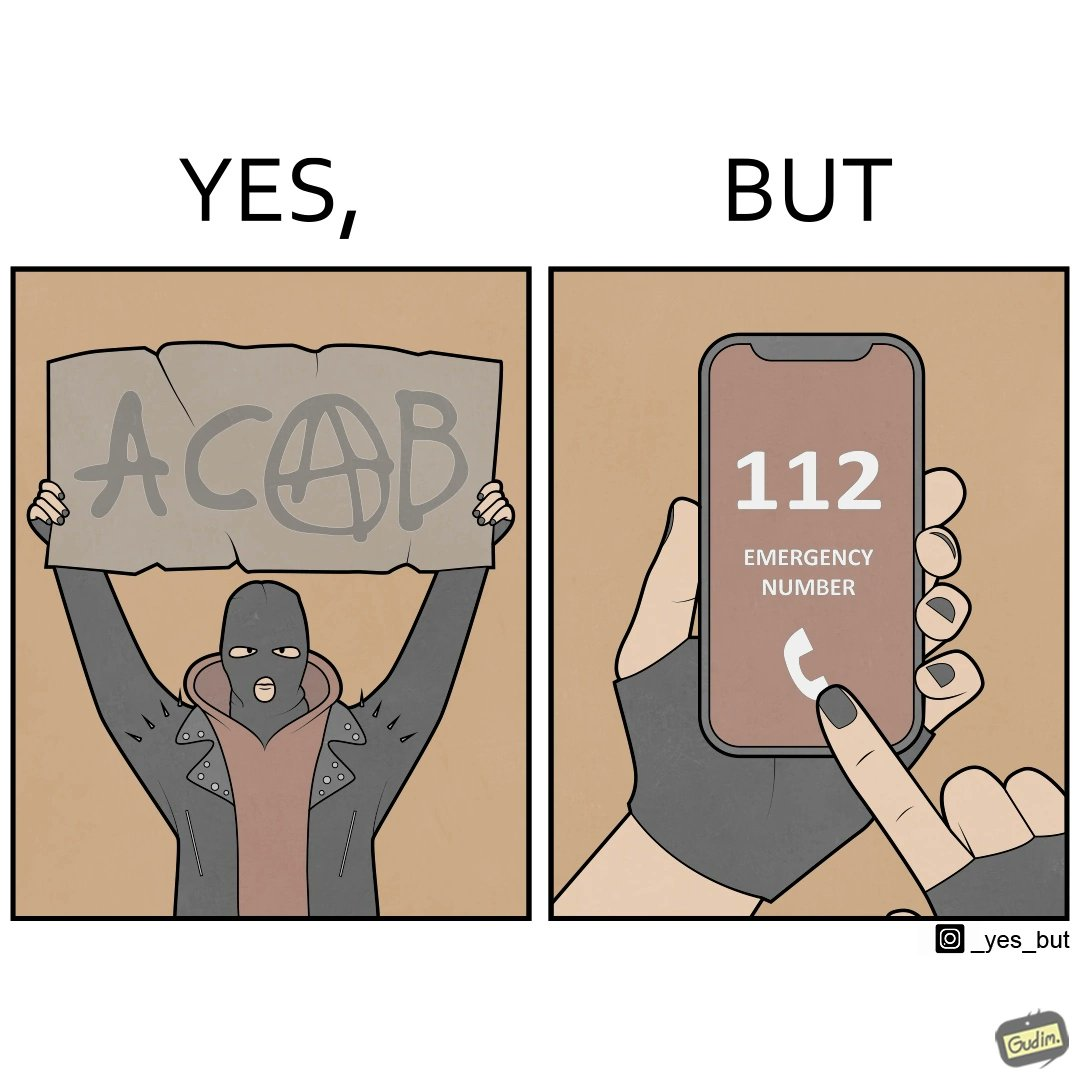Describe what you see in the left and right parts of this image. In the left part of the image: A person holding a sign that says the letters ACAB. The persons face is covered by a mask, they have black nails and they looks like they are protesting something. In the right part of the image: Person dialling 112 Emergency number on their phone. They have black nails 